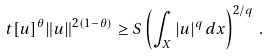Convert formula to latex. <formula><loc_0><loc_0><loc_500><loc_500>t [ u ] ^ { \theta } \| u \| ^ { 2 ( 1 - \theta ) } \geq S \left ( \int _ { X } | u | ^ { q } \, d x \right ) ^ { 2 / q } \, .</formula> 